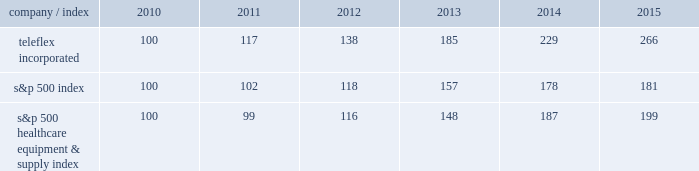Stock performance graph the following graph provides a comparison of five year cumulative total stockholder returns of teleflex common stock , the standard & poor 2019s ( s&p ) 500 stock index and the s&p 500 healthcare equipment & supply index .
The annual changes for the five-year period shown on the graph are based on the assumption that $ 100 had been invested in teleflex common stock and each index on december 31 , 2010 and that all dividends were reinvested .
Market performance .
S&p 500 healthcare equipment & supply index 100 99 116 148 187 199 .
What is the total return of an investment of $ 1000000 in teleflex incorporated in 2010 and sold in 2015? 
Computations: ((1000000 / 100) * (266 - 100))
Answer: 1660000.0. 